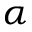Convert formula to latex. <formula><loc_0><loc_0><loc_500><loc_500>\alpha</formula> 